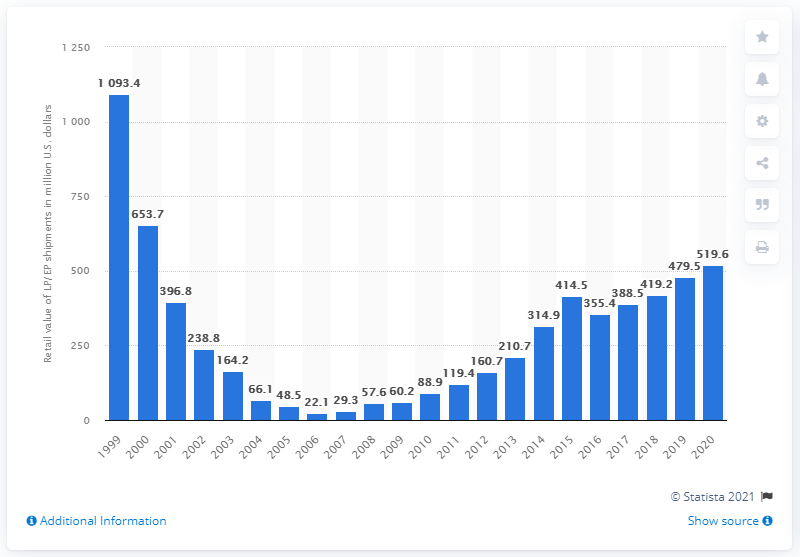Identify some key points in this picture. The retail value of all LPs and EPs shipped in the U.S. a year earlier was approximately $479.5 million. In 2020, the retail value of all LPs and EPs shipped in the U.S. was $519.6 million. 